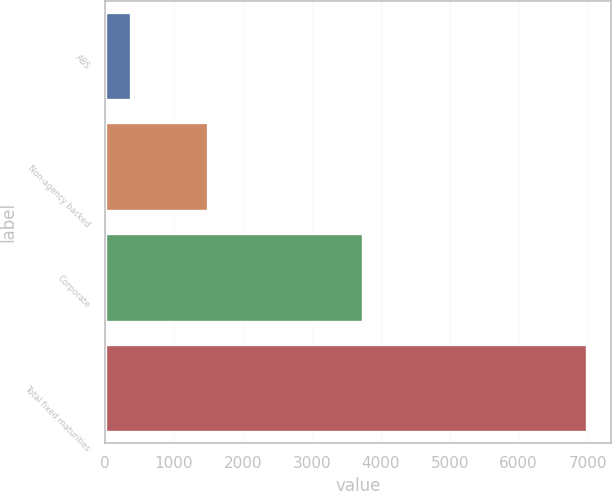<chart> <loc_0><loc_0><loc_500><loc_500><bar_chart><fcel>ABS<fcel>Non-agency backed<fcel>Corporate<fcel>Total fixed maturities<nl><fcel>380<fcel>1489<fcel>3740<fcel>6994<nl></chart> 